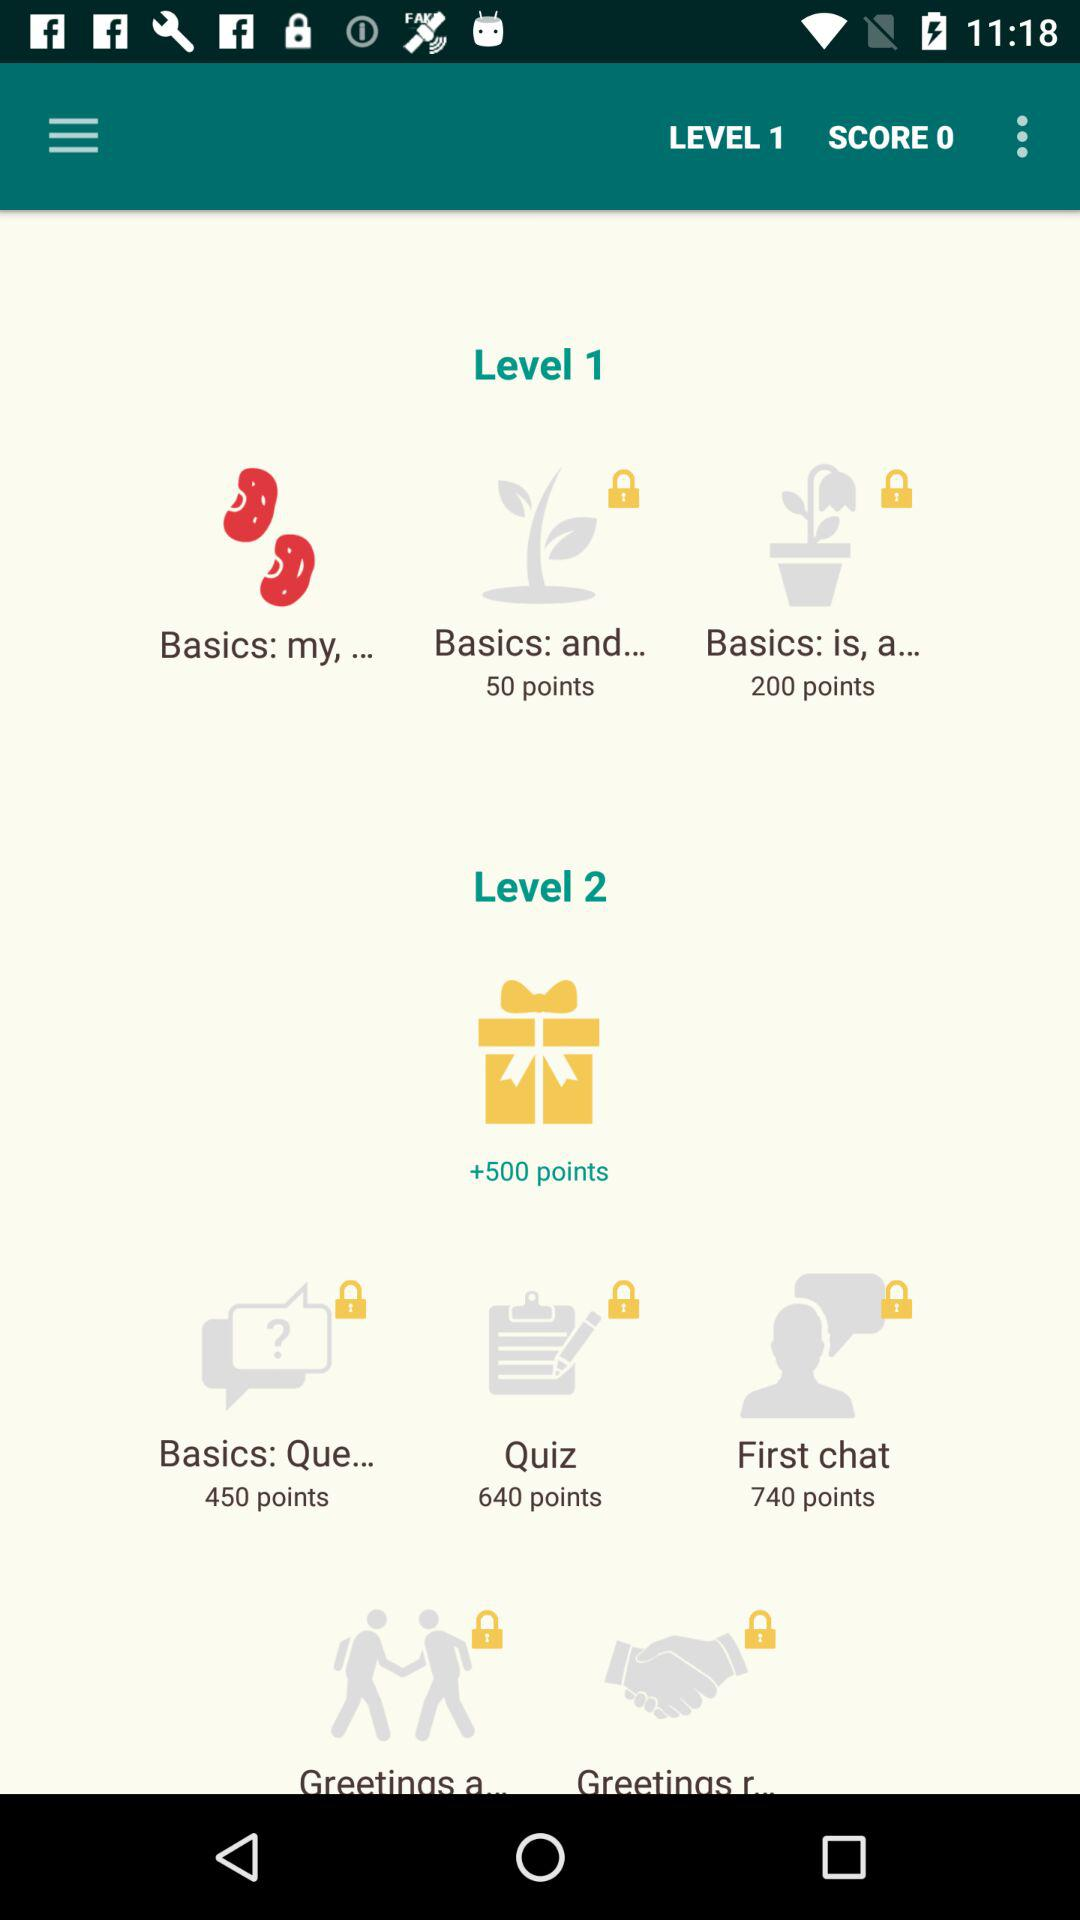How many "Basics: is, a..." points are in level 1? There are 200 "Basics: is, a..." points in level 1. 